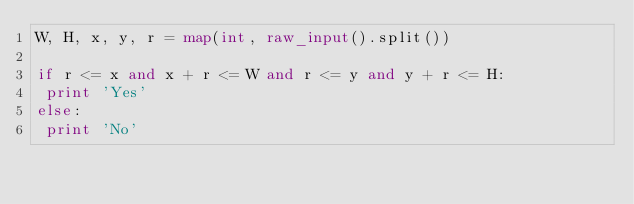<code> <loc_0><loc_0><loc_500><loc_500><_Python_>W, H, x, y, r = map(int, raw_input().split())
 
if r <= x and x + r <= W and r <= y and y + r <= H:
 print 'Yes'
else:
 print 'No'</code> 